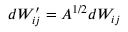<formula> <loc_0><loc_0><loc_500><loc_500>d W _ { i j } ^ { \prime } = A ^ { 1 / 2 } d W _ { i j }</formula> 